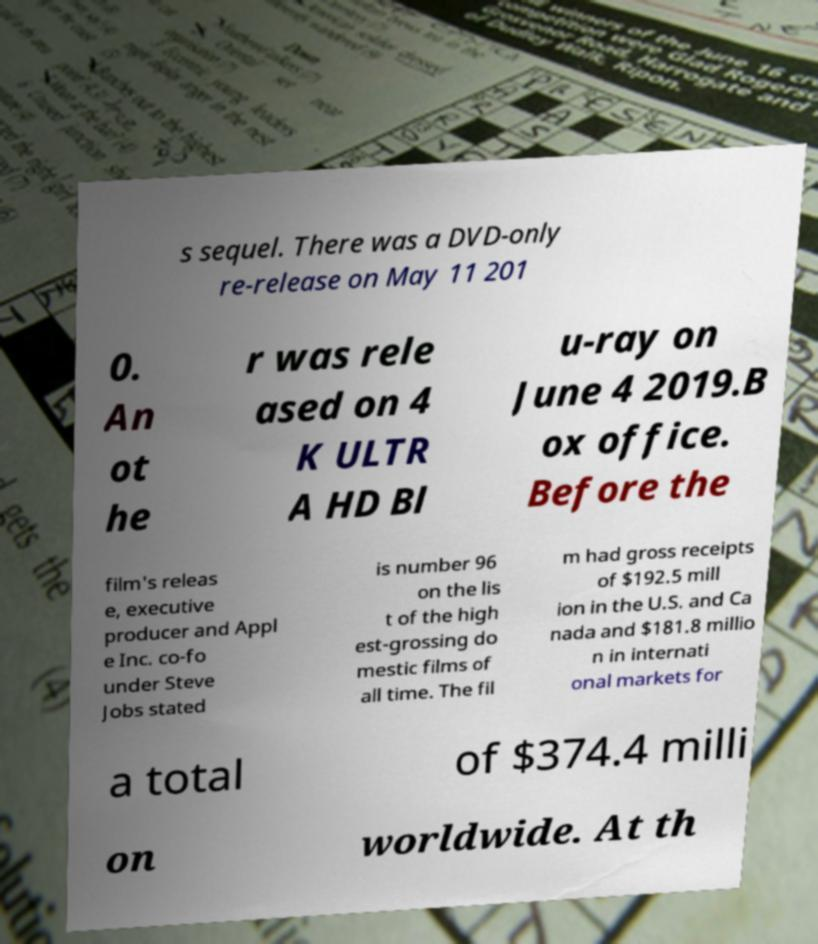Please read and relay the text visible in this image. What does it say? s sequel. There was a DVD-only re-release on May 11 201 0. An ot he r was rele ased on 4 K ULTR A HD Bl u-ray on June 4 2019.B ox office. Before the film's releas e, executive producer and Appl e Inc. co-fo under Steve Jobs stated is number 96 on the lis t of the high est-grossing do mestic films of all time. The fil m had gross receipts of $192.5 mill ion in the U.S. and Ca nada and $181.8 millio n in internati onal markets for a total of $374.4 milli on worldwide. At th 